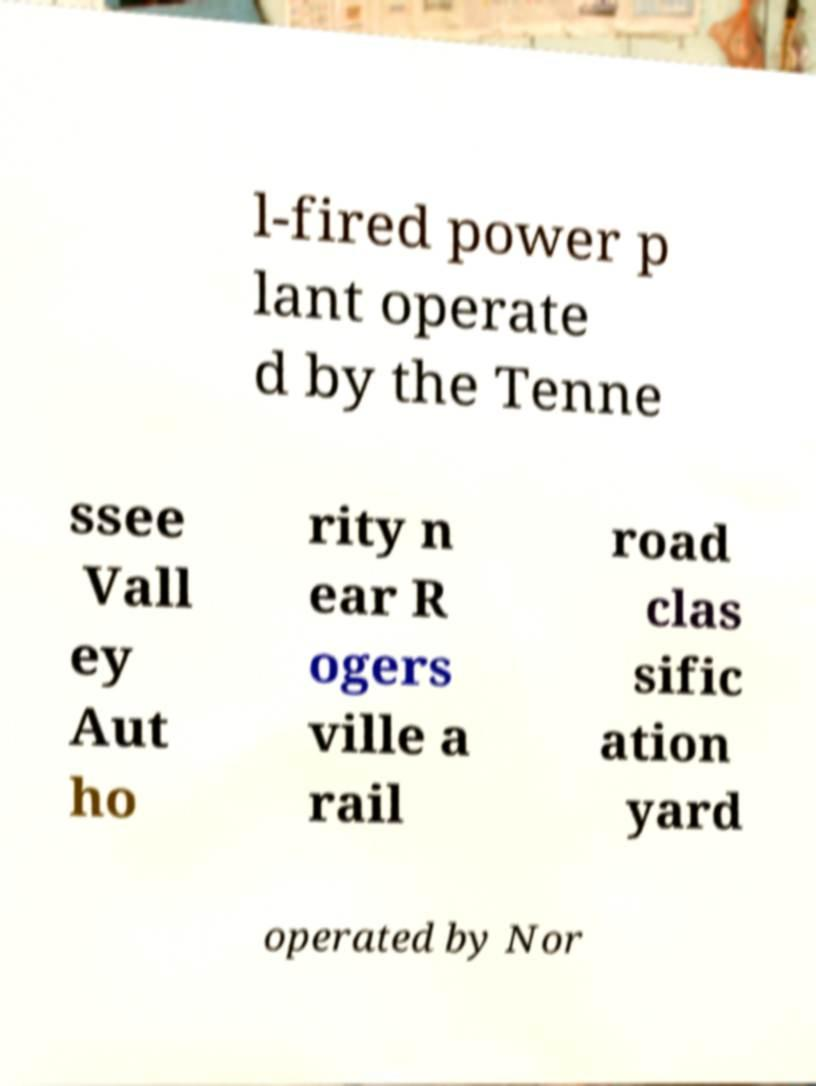For documentation purposes, I need the text within this image transcribed. Could you provide that? l-fired power p lant operate d by the Tenne ssee Vall ey Aut ho rity n ear R ogers ville a rail road clas sific ation yard operated by Nor 